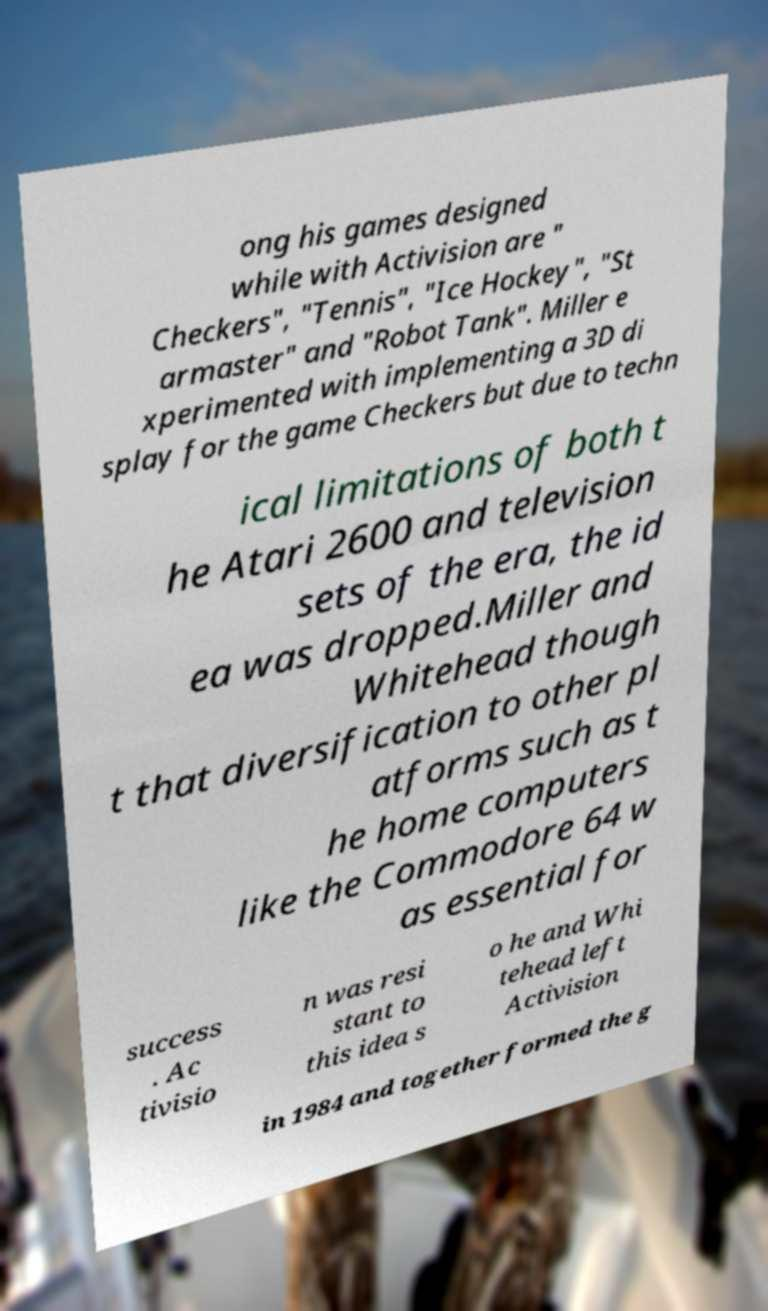What messages or text are displayed in this image? I need them in a readable, typed format. ong his games designed while with Activision are " Checkers", "Tennis", "Ice Hockey", "St armaster" and "Robot Tank". Miller e xperimented with implementing a 3D di splay for the game Checkers but due to techn ical limitations of both t he Atari 2600 and television sets of the era, the id ea was dropped.Miller and Whitehead though t that diversification to other pl atforms such as t he home computers like the Commodore 64 w as essential for success . Ac tivisio n was resi stant to this idea s o he and Whi tehead left Activision in 1984 and together formed the g 